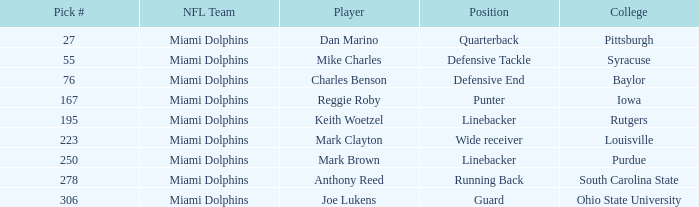Which Position has a Pick # lower than 278 for Player Charles Benson? Defensive End. 